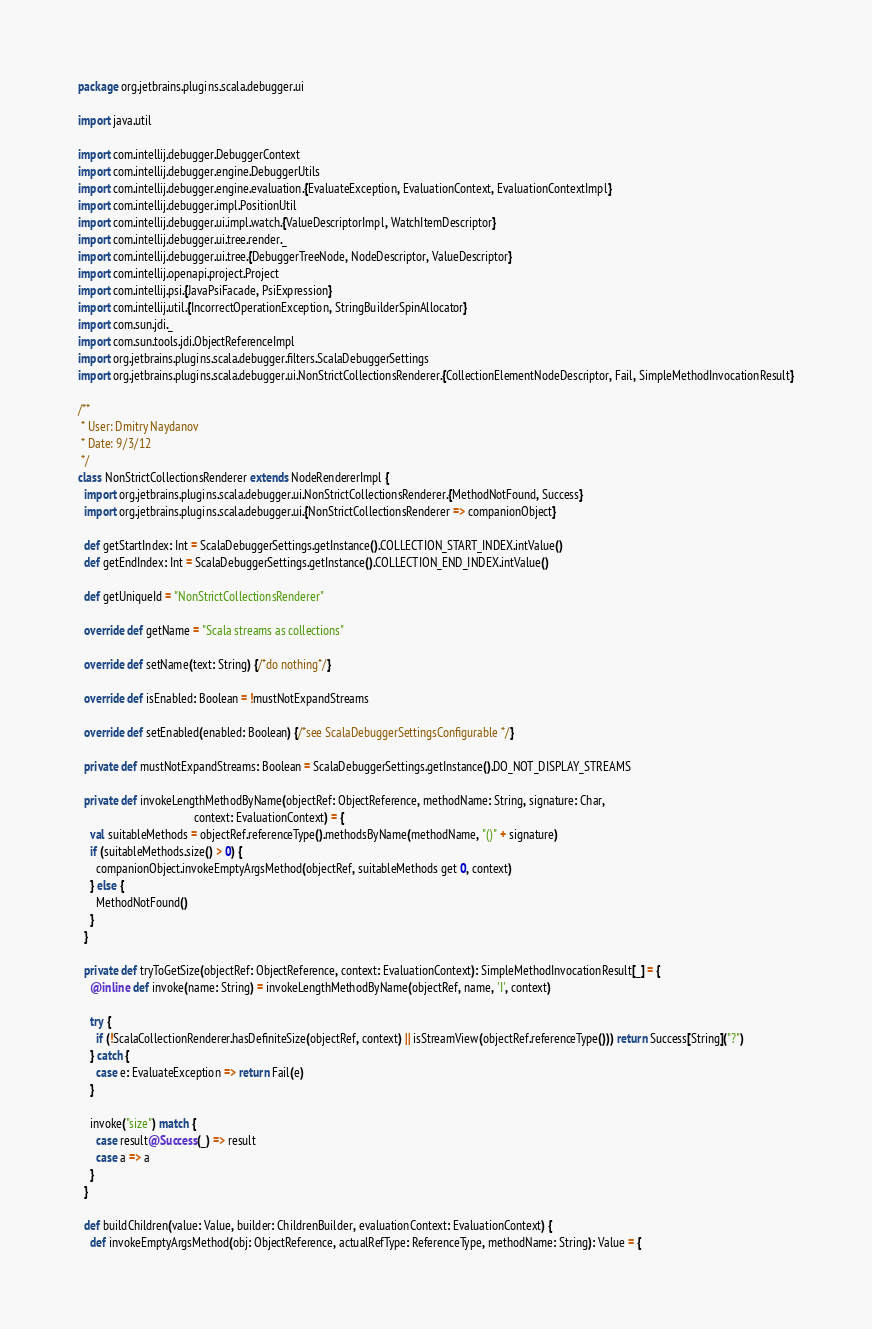<code> <loc_0><loc_0><loc_500><loc_500><_Scala_>package org.jetbrains.plugins.scala.debugger.ui

import java.util

import com.intellij.debugger.DebuggerContext
import com.intellij.debugger.engine.DebuggerUtils
import com.intellij.debugger.engine.evaluation.{EvaluateException, EvaluationContext, EvaluationContextImpl}
import com.intellij.debugger.impl.PositionUtil
import com.intellij.debugger.ui.impl.watch.{ValueDescriptorImpl, WatchItemDescriptor}
import com.intellij.debugger.ui.tree.render._
import com.intellij.debugger.ui.tree.{DebuggerTreeNode, NodeDescriptor, ValueDescriptor}
import com.intellij.openapi.project.Project
import com.intellij.psi.{JavaPsiFacade, PsiExpression}
import com.intellij.util.{IncorrectOperationException, StringBuilderSpinAllocator}
import com.sun.jdi._
import com.sun.tools.jdi.ObjectReferenceImpl
import org.jetbrains.plugins.scala.debugger.filters.ScalaDebuggerSettings
import org.jetbrains.plugins.scala.debugger.ui.NonStrictCollectionsRenderer.{CollectionElementNodeDescriptor, Fail, SimpleMethodInvocationResult}

/**
 * User: Dmitry Naydanov
 * Date: 9/3/12
 */
class NonStrictCollectionsRenderer extends NodeRendererImpl {
  import org.jetbrains.plugins.scala.debugger.ui.NonStrictCollectionsRenderer.{MethodNotFound, Success}
  import org.jetbrains.plugins.scala.debugger.ui.{NonStrictCollectionsRenderer => companionObject}

  def getStartIndex: Int = ScalaDebuggerSettings.getInstance().COLLECTION_START_INDEX.intValue()
  def getEndIndex: Int = ScalaDebuggerSettings.getInstance().COLLECTION_END_INDEX.intValue()

  def getUniqueId = "NonStrictCollectionsRenderer"

  override def getName = "Scala streams as collections"

  override def setName(text: String) {/*do nothing*/}

  override def isEnabled: Boolean = !mustNotExpandStreams

  override def setEnabled(enabled: Boolean) {/*see ScalaDebuggerSettingsConfigurable */}

  private def mustNotExpandStreams: Boolean = ScalaDebuggerSettings.getInstance().DO_NOT_DISPLAY_STREAMS

  private def invokeLengthMethodByName(objectRef: ObjectReference, methodName: String, signature: Char,
                                       context: EvaluationContext) = {
    val suitableMethods = objectRef.referenceType().methodsByName(methodName, "()" + signature)
    if (suitableMethods.size() > 0) {
      companionObject.invokeEmptyArgsMethod(objectRef, suitableMethods get 0, context)
    } else {
      MethodNotFound()
    }
  }

  private def tryToGetSize(objectRef: ObjectReference, context: EvaluationContext): SimpleMethodInvocationResult[_] = {
    @inline def invoke(name: String) = invokeLengthMethodByName(objectRef, name, 'I', context)

    try {
      if (!ScalaCollectionRenderer.hasDefiniteSize(objectRef, context) || isStreamView(objectRef.referenceType())) return Success[String]("?")
    } catch {
      case e: EvaluateException => return Fail(e)
    }

    invoke("size") match {
      case result@Success(_) => result
      case a => a
    }
  }

  def buildChildren(value: Value, builder: ChildrenBuilder, evaluationContext: EvaluationContext) {
    def invokeEmptyArgsMethod(obj: ObjectReference, actualRefType: ReferenceType, methodName: String): Value = {</code> 